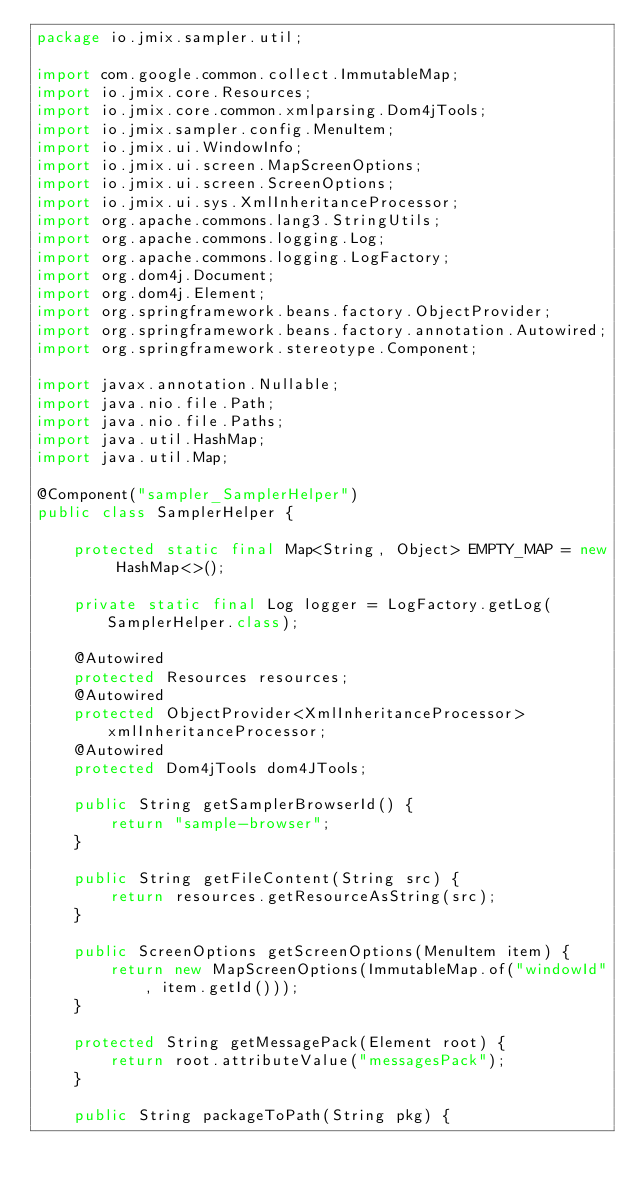<code> <loc_0><loc_0><loc_500><loc_500><_Java_>package io.jmix.sampler.util;

import com.google.common.collect.ImmutableMap;
import io.jmix.core.Resources;
import io.jmix.core.common.xmlparsing.Dom4jTools;
import io.jmix.sampler.config.MenuItem;
import io.jmix.ui.WindowInfo;
import io.jmix.ui.screen.MapScreenOptions;
import io.jmix.ui.screen.ScreenOptions;
import io.jmix.ui.sys.XmlInheritanceProcessor;
import org.apache.commons.lang3.StringUtils;
import org.apache.commons.logging.Log;
import org.apache.commons.logging.LogFactory;
import org.dom4j.Document;
import org.dom4j.Element;
import org.springframework.beans.factory.ObjectProvider;
import org.springframework.beans.factory.annotation.Autowired;
import org.springframework.stereotype.Component;

import javax.annotation.Nullable;
import java.nio.file.Path;
import java.nio.file.Paths;
import java.util.HashMap;
import java.util.Map;

@Component("sampler_SamplerHelper")
public class SamplerHelper {

    protected static final Map<String, Object> EMPTY_MAP = new HashMap<>();

    private static final Log logger = LogFactory.getLog(SamplerHelper.class);

    @Autowired
    protected Resources resources;
    @Autowired
    protected ObjectProvider<XmlInheritanceProcessor> xmlInheritanceProcessor;
    @Autowired
    protected Dom4jTools dom4JTools;

    public String getSamplerBrowserId() {
        return "sample-browser";
    }

    public String getFileContent(String src) {
        return resources.getResourceAsString(src);
    }

    public ScreenOptions getScreenOptions(MenuItem item) {
        return new MapScreenOptions(ImmutableMap.of("windowId", item.getId()));
    }

    protected String getMessagePack(Element root) {
        return root.attributeValue("messagesPack");
    }

    public String packageToPath(String pkg) {</code> 